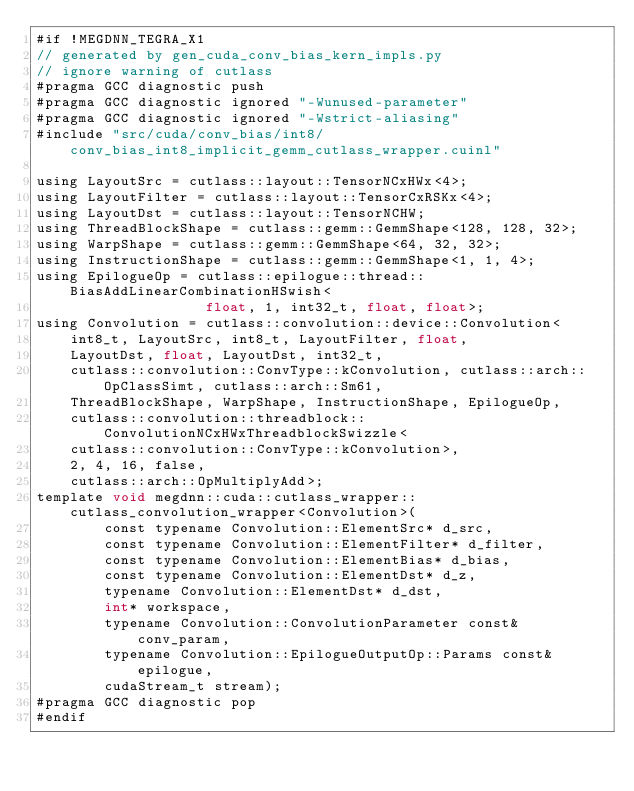Convert code to text. <code><loc_0><loc_0><loc_500><loc_500><_Cuda_>#if !MEGDNN_TEGRA_X1
// generated by gen_cuda_conv_bias_kern_impls.py
// ignore warning of cutlass
#pragma GCC diagnostic push
#pragma GCC diagnostic ignored "-Wunused-parameter"
#pragma GCC diagnostic ignored "-Wstrict-aliasing"
#include "src/cuda/conv_bias/int8/conv_bias_int8_implicit_gemm_cutlass_wrapper.cuinl"

using LayoutSrc = cutlass::layout::TensorNCxHWx<4>;
using LayoutFilter = cutlass::layout::TensorCxRSKx<4>;
using LayoutDst = cutlass::layout::TensorNCHW;
using ThreadBlockShape = cutlass::gemm::GemmShape<128, 128, 32>;
using WarpShape = cutlass::gemm::GemmShape<64, 32, 32>;
using InstructionShape = cutlass::gemm::GemmShape<1, 1, 4>;
using EpilogueOp = cutlass::epilogue::thread::BiasAddLinearCombinationHSwish<
                    float, 1, int32_t, float, float>;
using Convolution = cutlass::convolution::device::Convolution<
    int8_t, LayoutSrc, int8_t, LayoutFilter, float, 
    LayoutDst, float, LayoutDst, int32_t, 
    cutlass::convolution::ConvType::kConvolution, cutlass::arch::OpClassSimt, cutlass::arch::Sm61, 
    ThreadBlockShape, WarpShape, InstructionShape, EpilogueOp, 
    cutlass::convolution::threadblock::ConvolutionNCxHWxThreadblockSwizzle<
    cutlass::convolution::ConvType::kConvolution>, 
    2, 4, 16, false, 
    cutlass::arch::OpMultiplyAdd>;
template void megdnn::cuda::cutlass_wrapper::cutlass_convolution_wrapper<Convolution>(
        const typename Convolution::ElementSrc* d_src, 
        const typename Convolution::ElementFilter* d_filter, 
        const typename Convolution::ElementBias* d_bias, 
        const typename Convolution::ElementDst* d_z, 
        typename Convolution::ElementDst* d_dst, 
        int* workspace, 
        typename Convolution::ConvolutionParameter const& conv_param, 
        typename Convolution::EpilogueOutputOp::Params const& epilogue, 
        cudaStream_t stream);
#pragma GCC diagnostic pop
#endif
</code> 